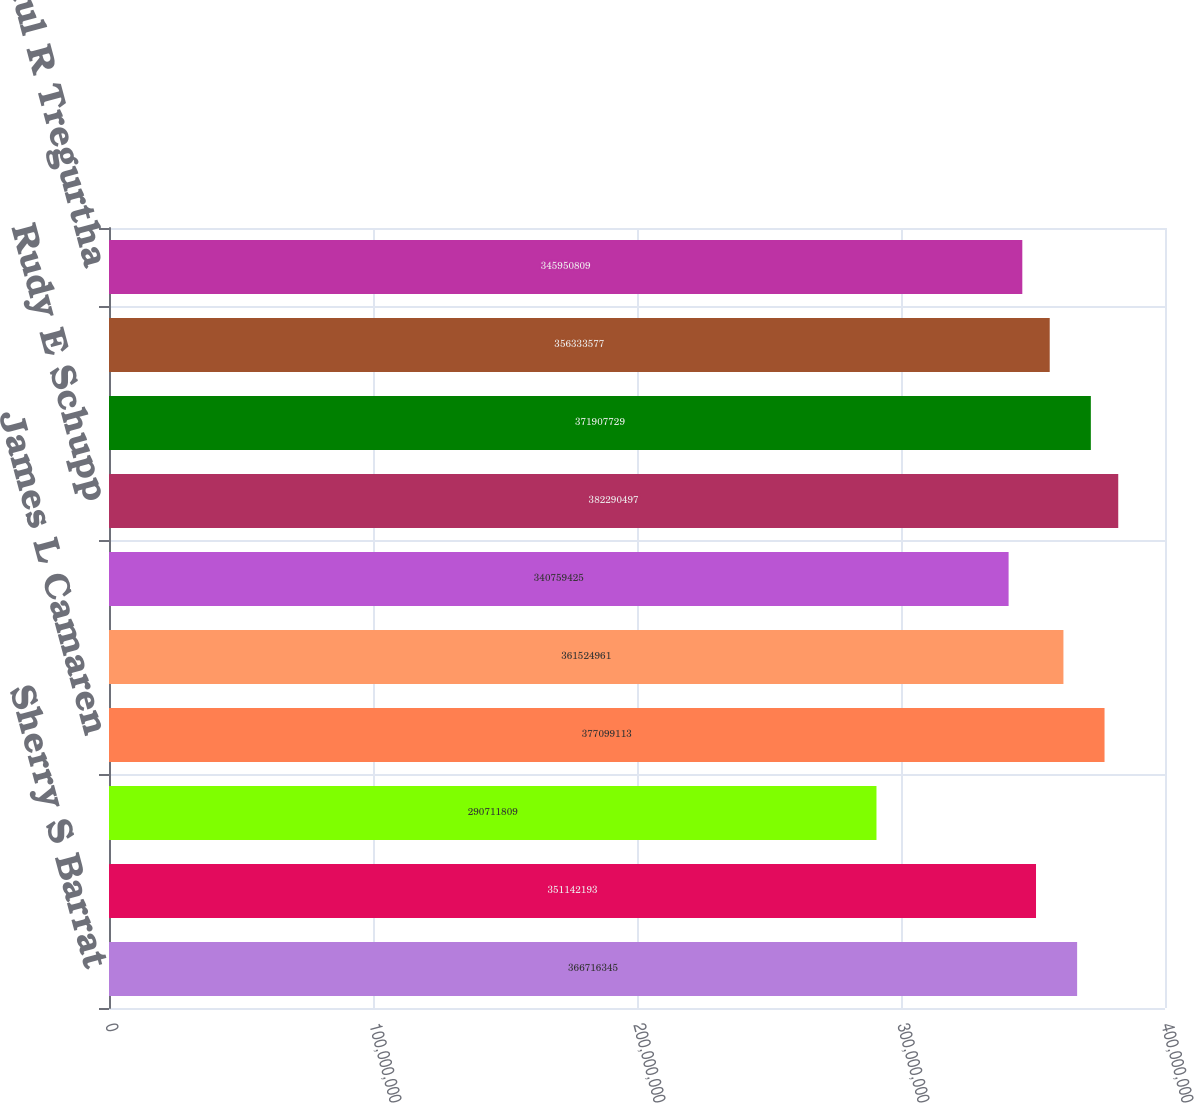Convert chart to OTSL. <chart><loc_0><loc_0><loc_500><loc_500><bar_chart><fcel>Sherry S Barrat<fcel>Robert M Beall II<fcel>J Hyatt Brown<fcel>James L Camaren<fcel>J Brian Ferguson<fcel>Lewis Hay III<fcel>Rudy E Schupp<fcel>Michael H Thaman<fcel>Hansel E Tookes II<fcel>Paul R Tregurtha<nl><fcel>3.66716e+08<fcel>3.51142e+08<fcel>2.90712e+08<fcel>3.77099e+08<fcel>3.61525e+08<fcel>3.40759e+08<fcel>3.8229e+08<fcel>3.71908e+08<fcel>3.56334e+08<fcel>3.45951e+08<nl></chart> 